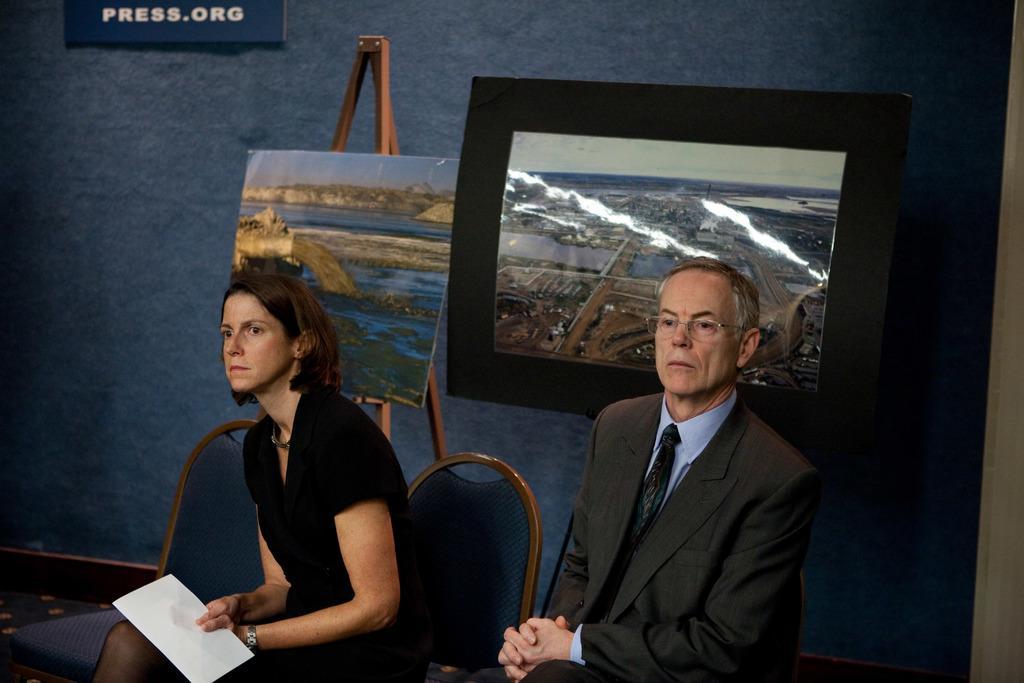In one or two sentences, can you explain what this image depicts? In this image I can see two persons sitting, the person at right is wearing black blazer and blue color shirt and the person at left is wearing black color dress, background I can see the screen and the wall is in blue color. 